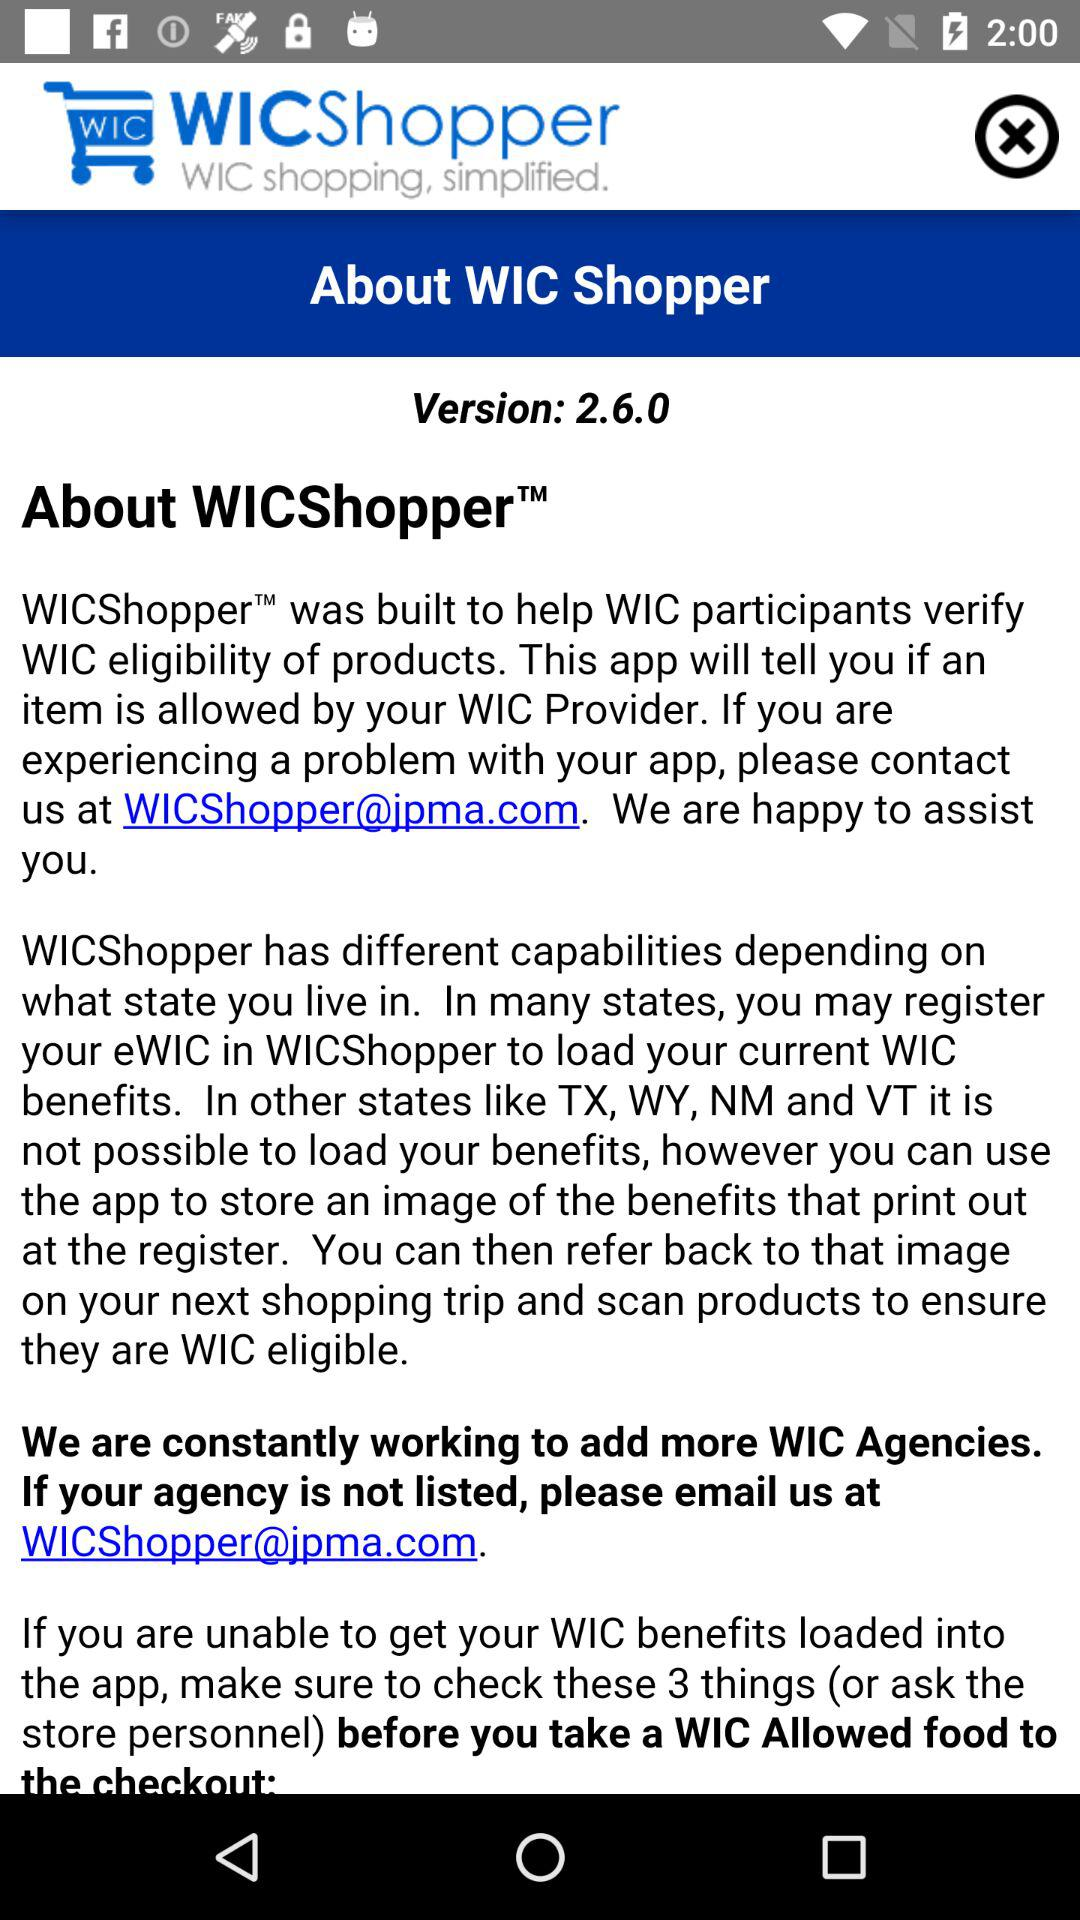What is the shown email address? The shown email address is WICShopper@jpma.com. 